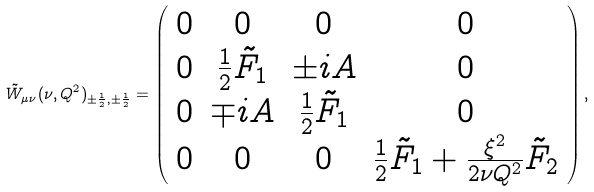<formula> <loc_0><loc_0><loc_500><loc_500>\tilde { W } _ { \mu \nu } ( \nu , Q ^ { 2 } ) _ { \pm \frac { 1 } { 2 } , \pm \frac { 1 } { 2 } } = \left ( \begin{array} { c c c c } 0 & 0 & 0 & 0 \\ 0 & \frac { 1 } { 2 } \tilde { F } _ { 1 } & \pm i A & 0 \\ 0 & \mp i A & \frac { 1 } { 2 } \tilde { F } _ { 1 } & 0 \\ 0 & 0 & 0 & \frac { 1 } { 2 } \tilde { F } _ { 1 } + \frac { \xi ^ { 2 } } { 2 \nu Q ^ { 2 } } \tilde { F } _ { 2 } \end{array} \right ) ,</formula> 